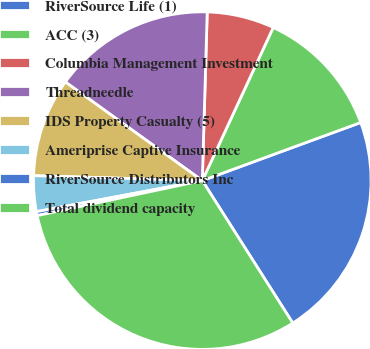Convert chart to OTSL. <chart><loc_0><loc_0><loc_500><loc_500><pie_chart><fcel>RiverSource Life (1)<fcel>ACC (3)<fcel>Columbia Management Investment<fcel>Threadneedle<fcel>IDS Property Casualty (5)<fcel>Ameriprise Captive Insurance<fcel>RiverSource Distributors Inc<fcel>Total dividend capacity<nl><fcel>21.59%<fcel>12.5%<fcel>6.44%<fcel>15.53%<fcel>9.47%<fcel>3.41%<fcel>0.38%<fcel>30.68%<nl></chart> 